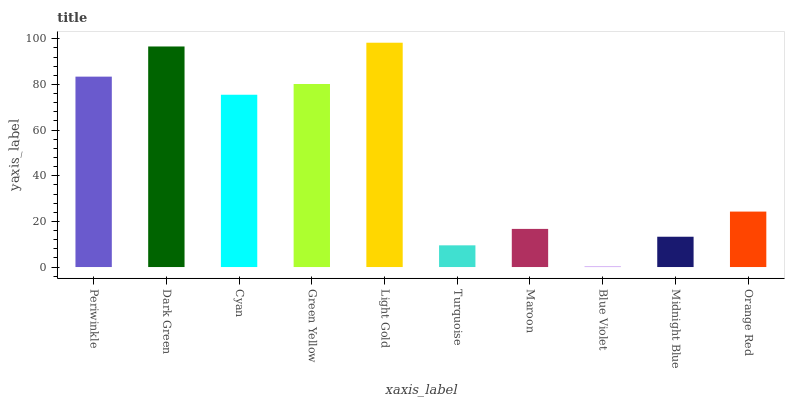Is Blue Violet the minimum?
Answer yes or no. Yes. Is Light Gold the maximum?
Answer yes or no. Yes. Is Dark Green the minimum?
Answer yes or no. No. Is Dark Green the maximum?
Answer yes or no. No. Is Dark Green greater than Periwinkle?
Answer yes or no. Yes. Is Periwinkle less than Dark Green?
Answer yes or no. Yes. Is Periwinkle greater than Dark Green?
Answer yes or no. No. Is Dark Green less than Periwinkle?
Answer yes or no. No. Is Cyan the high median?
Answer yes or no. Yes. Is Orange Red the low median?
Answer yes or no. Yes. Is Turquoise the high median?
Answer yes or no. No. Is Maroon the low median?
Answer yes or no. No. 